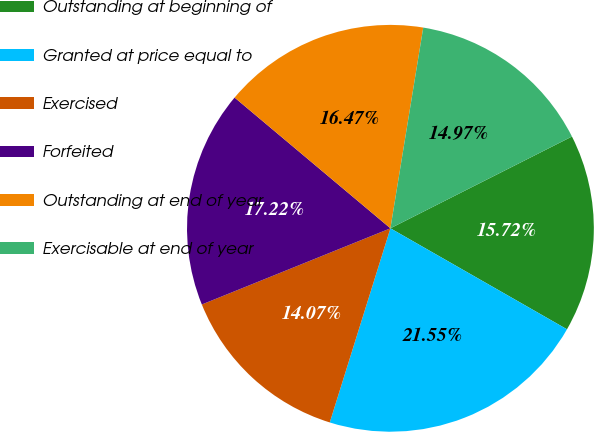Convert chart. <chart><loc_0><loc_0><loc_500><loc_500><pie_chart><fcel>Outstanding at beginning of<fcel>Granted at price equal to<fcel>Exercised<fcel>Forfeited<fcel>Outstanding at end of year<fcel>Exercisable at end of year<nl><fcel>15.72%<fcel>21.55%<fcel>14.07%<fcel>17.22%<fcel>16.47%<fcel>14.97%<nl></chart> 